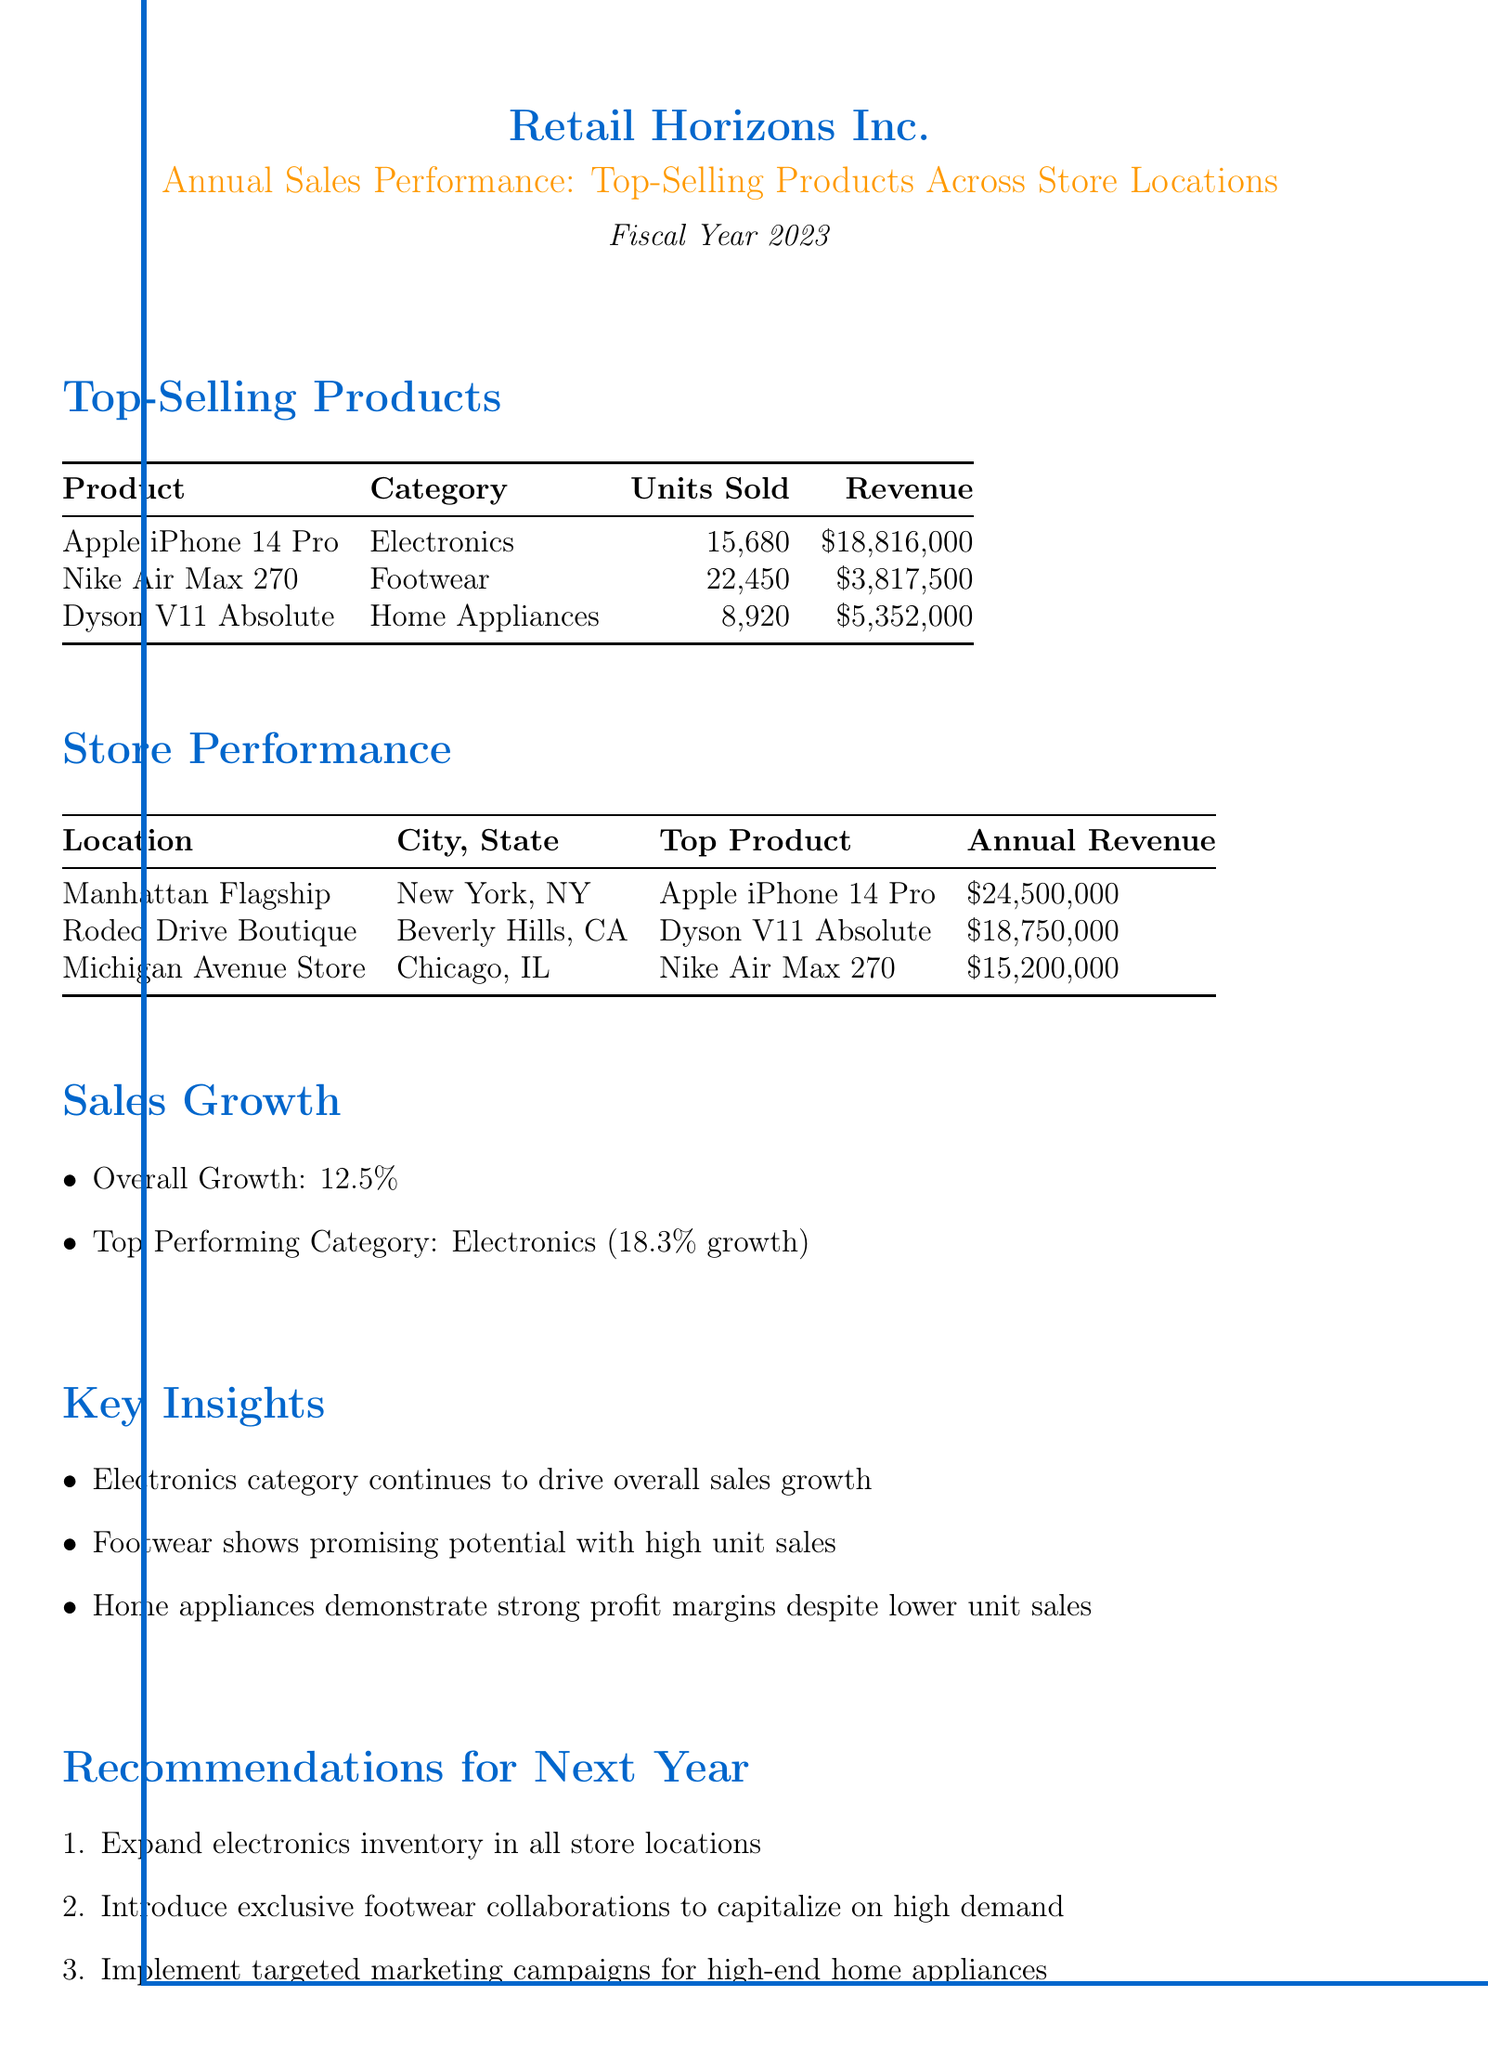What is the title of the report? The title of the report is mentioned at the beginning of the document, which is "Annual Sales Performance: Top-Selling Products Across Store Locations."
Answer: Annual Sales Performance: Top-Selling Products Across Store Locations Who is the top-selling product in the electronics category? The document lists the top-selling products and specifies that the "Apple iPhone 14 Pro" is categorized as electronics.
Answer: Apple iPhone 14 Pro What is the total number of units sold for Nike Air Max 270? The report provides the number of units sold for each product, indicating "22,450" for Nike Air Max 270.
Answer: 22,450 What was the annual revenue for the Manhattan Flagship store? The revenue for each store is listed, showing that the Manhattan Flagship store generated "$24,500,000."
Answer: $24,500,000 Which category had the highest growth percentage? The growth percentages for different categories are provided, stating that "Electronics" is the top-performing category with "18.3%" growth.
Answer: Electronics What insight does the report provide about footwear? The document includes key insights that mention footwear and describes it as having "promising potential with high unit sales."
Answer: Promising potential with high unit sales What is one recommendation for next year? The recommendations section provides actionable suggestions, one of which is to "Expand electronics inventory in all store locations."
Answer: Expand electronics inventory in all store locations What is the overall sales growth percentage? The report explicitly states the overall sales growth percentage, which is "12.5%."
Answer: 12.5% Which store's top product generated the highest revenue? By comparing annual revenues, it is clear that the store with the top product generating the highest revenue is the Manhattan Flagship store with "Apple iPhone 14 Pro."
Answer: Manhattan Flagship store 